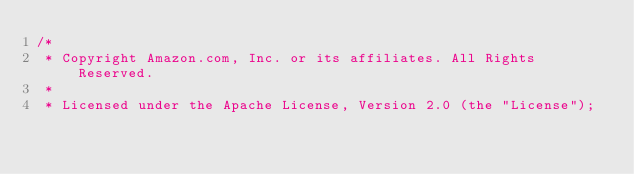<code> <loc_0><loc_0><loc_500><loc_500><_C_>/*
 * Copyright Amazon.com, Inc. or its affiliates. All Rights Reserved.
 *
 * Licensed under the Apache License, Version 2.0 (the "License");</code> 